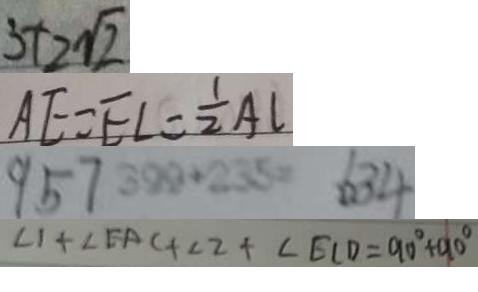<formula> <loc_0><loc_0><loc_500><loc_500>3 + 2 \sqrt { 2 } 
 A E = E L = \frac { 1 } { 2 } A L 
 9 5 7 3 9 9 + 2 3 5 = 6 3 4 
 \angle 1 + \angle E A C + \angle 2 + \angle E C D = 9 0 ^ { \circ } + 9 0 ^ { \circ }</formula> 